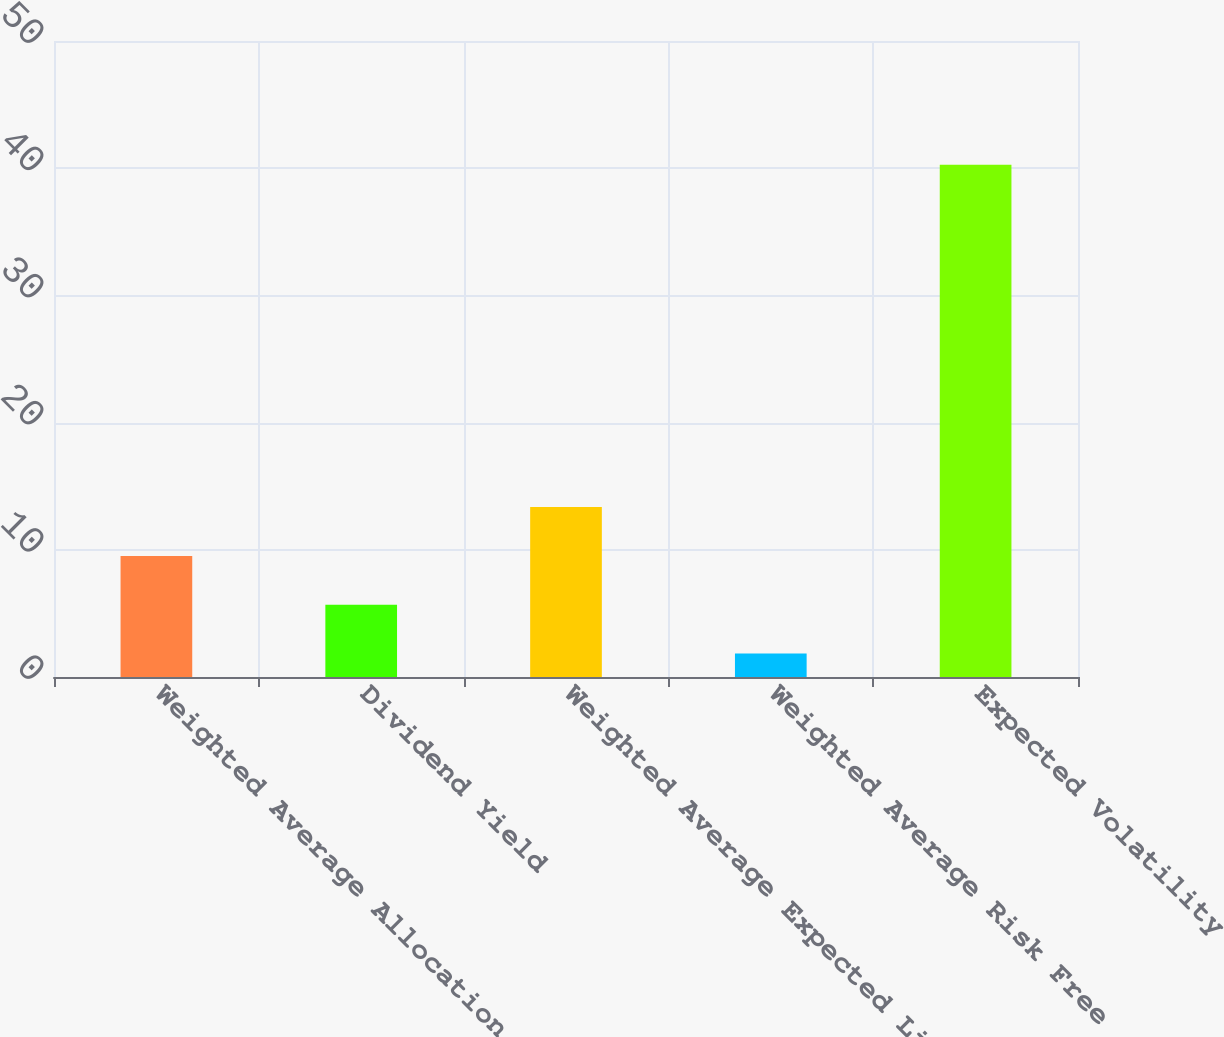<chart> <loc_0><loc_0><loc_500><loc_500><bar_chart><fcel>Weighted Average Allocation<fcel>Dividend Yield<fcel>Weighted Average Expected Life<fcel>Weighted Average Risk Free<fcel>Expected Volatility<nl><fcel>9.52<fcel>5.68<fcel>13.36<fcel>1.84<fcel>40.28<nl></chart> 